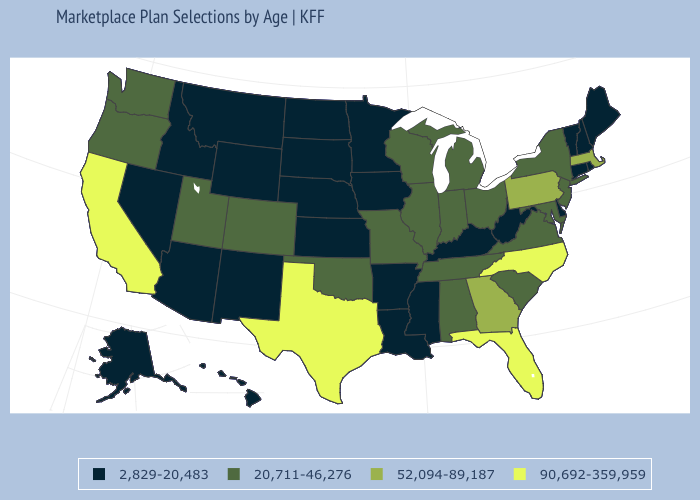What is the highest value in the USA?
Quick response, please. 90,692-359,959. Which states hav the highest value in the Northeast?
Quick response, please. Massachusetts, Pennsylvania. Does North Carolina have the same value as Texas?
Be succinct. Yes. What is the value of Illinois?
Be succinct. 20,711-46,276. Which states have the highest value in the USA?
Answer briefly. California, Florida, North Carolina, Texas. What is the value of Connecticut?
Quick response, please. 2,829-20,483. Among the states that border West Virginia , does Pennsylvania have the lowest value?
Write a very short answer. No. Does West Virginia have the lowest value in the USA?
Short answer required. Yes. What is the value of Michigan?
Quick response, please. 20,711-46,276. What is the value of Missouri?
Short answer required. 20,711-46,276. Does the first symbol in the legend represent the smallest category?
Answer briefly. Yes. What is the value of West Virginia?
Be succinct. 2,829-20,483. Which states have the highest value in the USA?
Be succinct. California, Florida, North Carolina, Texas. Name the states that have a value in the range 90,692-359,959?
Write a very short answer. California, Florida, North Carolina, Texas. What is the value of Washington?
Write a very short answer. 20,711-46,276. 